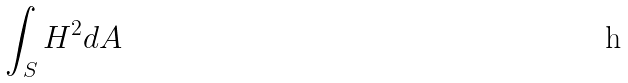<formula> <loc_0><loc_0><loc_500><loc_500>\int _ { S } H ^ { 2 } d A</formula> 